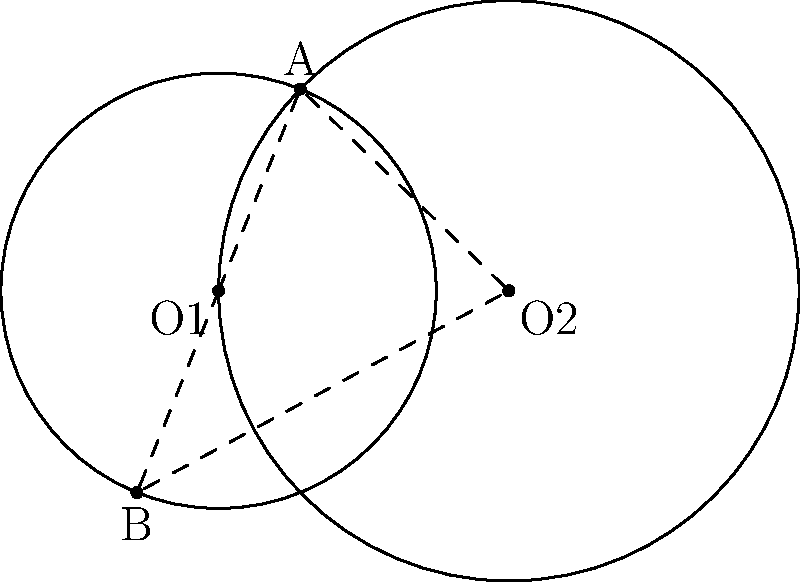In a tactical map of a conflict area, two overlapping zones of control are represented by intersecting circles. The centers of these circles, O1 and O2, are 4 units apart. The radius of the circle centered at O1 is 3 units, while the radius of the circle centered at O2 is 4 units. What is the length of the common chord AB formed by the intersection of these two circles? Let's approach this step-by-step:

1) First, we need to recall the formula for the length of a common chord when two circles intersect. If $d$ is the distance between the centers, and $r_1$ and $r_2$ are the radii of the circles, then the length of the common chord $L$ is given by:

   $$L = 2\sqrt{\frac{(r_1+r_2+d)(r_1+r_2-d)(r_1-r_2+d)(-r_1+r_2+d)}{4d^2}}$$

2) In this case, we have:
   $d = 4$ (distance between centers)
   $r_1 = 3$ (radius of circle centered at O1)
   $r_2 = 4$ (radius of circle centered at O2)

3) Let's substitute these values into the formula:

   $$L = 2\sqrt{\frac{(3+4+4)(3+4-4)(3-4+4)(-3+4+4)}{4(4^2)}}$$

4) Simplify inside the parentheses:

   $$L = 2\sqrt{\frac{(11)(3)(3)(5)}{64}}$$

5) Multiply the numbers in the numerator:

   $$L = 2\sqrt{\frac{495}{64}}$$

6) Simplify under the square root:

   $$L = 2\sqrt{\frac{495}{64}} = 2\sqrt{7.734375} \approx 5.56$$

Therefore, the length of the common chord AB is approximately 5.56 units.
Answer: $5.56$ units 